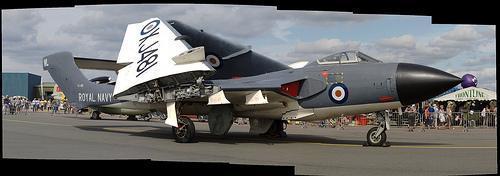How many airplanes in the picture?
Give a very brief answer. 1. 